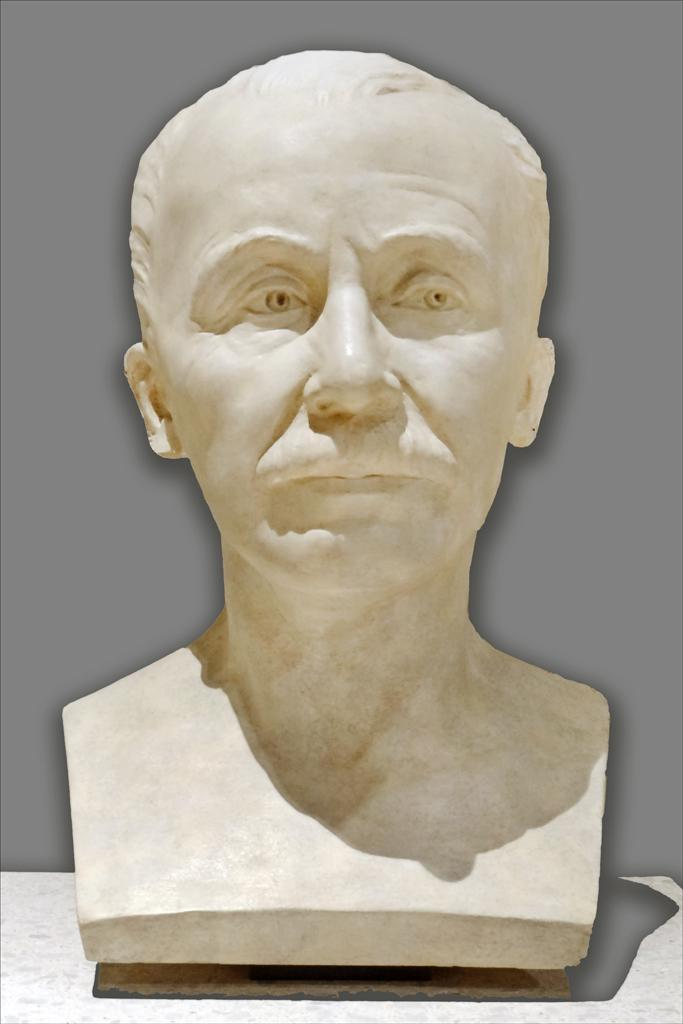What is the main subject in the image? There is a sculpture in the image. How many tickets are attached to the sculpture in the image? There is no mention of tickets or any other additional objects in the image; the image only contains a sculpture. 